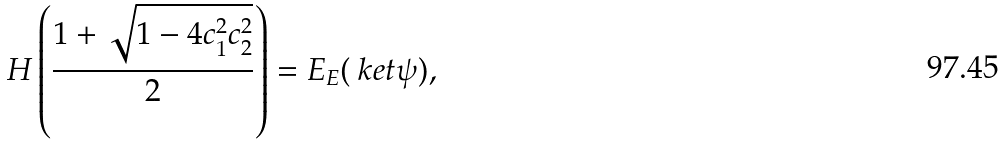Convert formula to latex. <formula><loc_0><loc_0><loc_500><loc_500>H \left ( \frac { 1 + \sqrt { 1 - 4 c _ { 1 } ^ { 2 } c _ { 2 } ^ { 2 } } } { 2 } \right ) = E _ { E } ( \ k e t { \psi } ) ,</formula> 